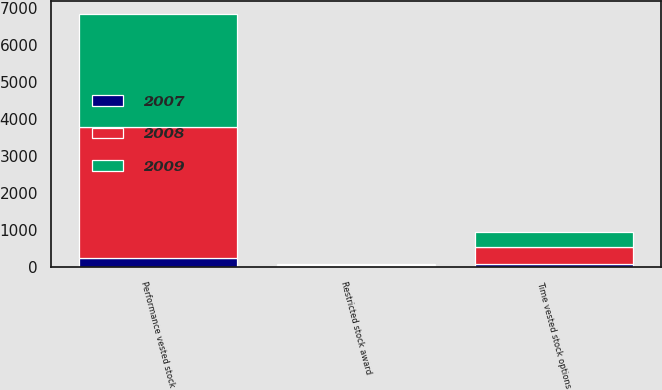Convert chart. <chart><loc_0><loc_0><loc_500><loc_500><stacked_bar_chart><ecel><fcel>Time vested stock options<fcel>Performance vested stock<fcel>Restricted stock award<nl><fcel>2007<fcel>87<fcel>247.5<fcel>31<nl><fcel>2008<fcel>464<fcel>3538<fcel>33<nl><fcel>2009<fcel>408<fcel>3047<fcel>32<nl></chart> 